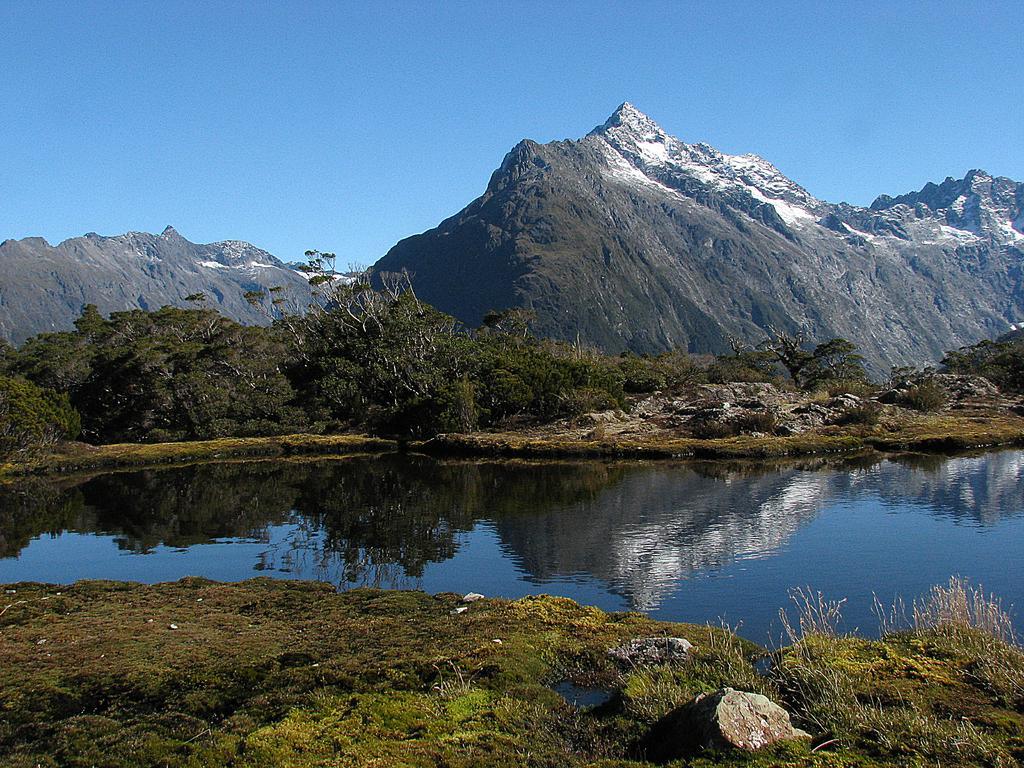Describe this image in one or two sentences. In this image I see the grass, water and number of trees. In the background I see the mountains and I see the clear sky. 